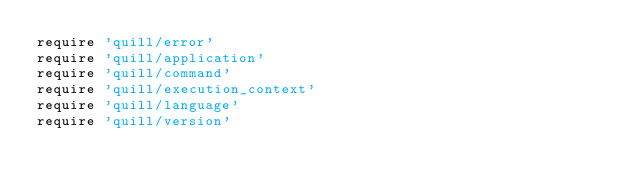<code> <loc_0><loc_0><loc_500><loc_500><_Ruby_>require 'quill/error'
require 'quill/application'
require 'quill/command'
require 'quill/execution_context'
require 'quill/language'
require 'quill/version'
</code> 